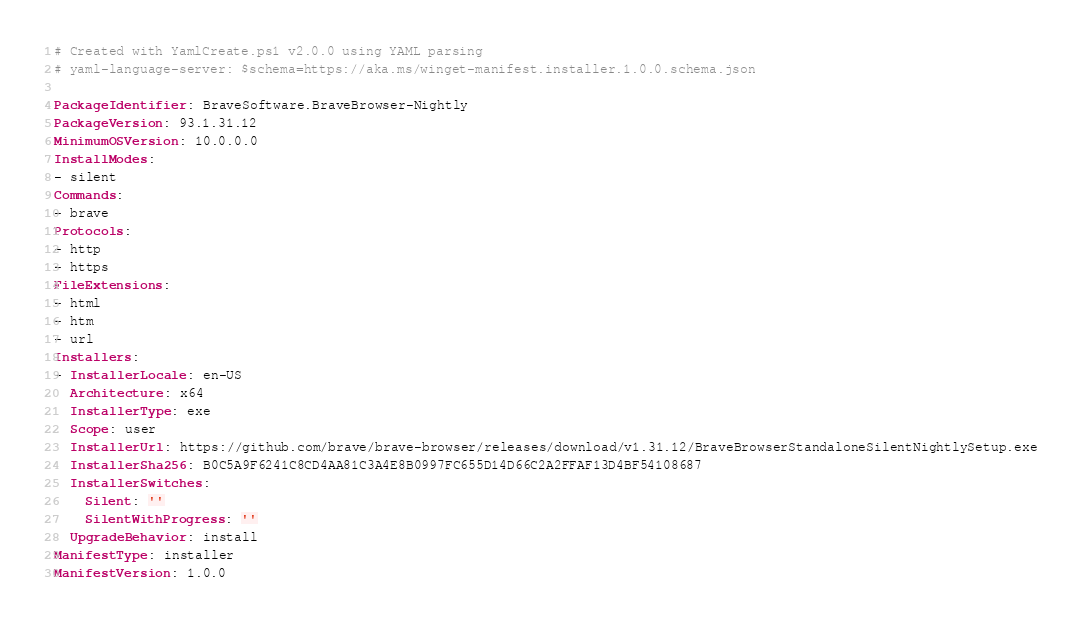Convert code to text. <code><loc_0><loc_0><loc_500><loc_500><_YAML_># Created with YamlCreate.ps1 v2.0.0 using YAML parsing
# yaml-language-server: $schema=https://aka.ms/winget-manifest.installer.1.0.0.schema.json

PackageIdentifier: BraveSoftware.BraveBrowser-Nightly
PackageVersion: 93.1.31.12
MinimumOSVersion: 10.0.0.0
InstallModes:
- silent
Commands:
- brave
Protocols:
- http
- https
FileExtensions:
- html
- htm
- url
Installers:
- InstallerLocale: en-US
  Architecture: x64
  InstallerType: exe
  Scope: user
  InstallerUrl: https://github.com/brave/brave-browser/releases/download/v1.31.12/BraveBrowserStandaloneSilentNightlySetup.exe
  InstallerSha256: B0C5A9F6241C8CD4AA81C3A4E8B0997FC655D14D66C2A2FFAF13D4BF54108687
  InstallerSwitches:
    Silent: ''
    SilentWithProgress: ''
  UpgradeBehavior: install
ManifestType: installer
ManifestVersion: 1.0.0
</code> 